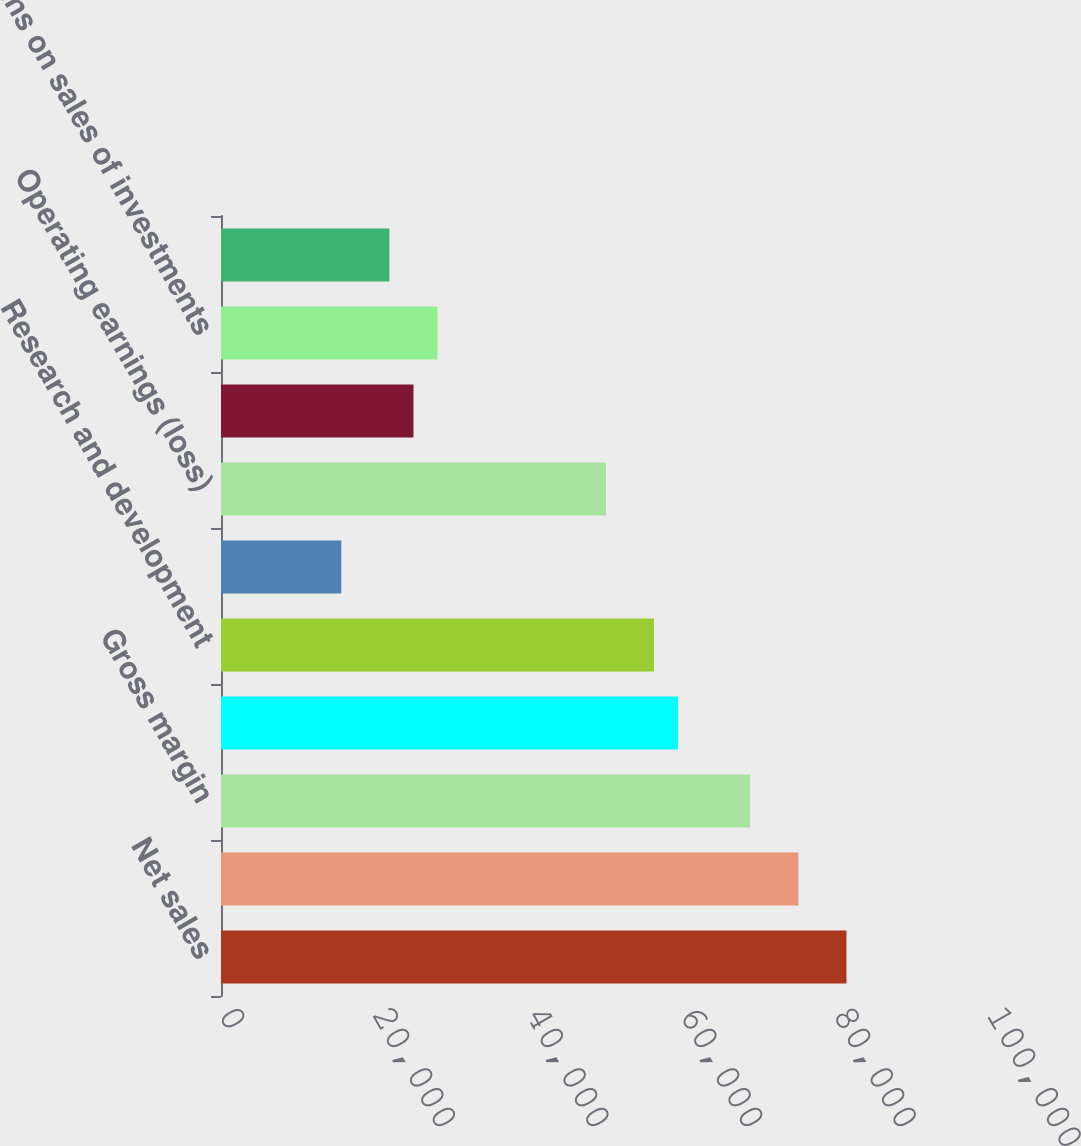Convert chart to OTSL. <chart><loc_0><loc_0><loc_500><loc_500><bar_chart><fcel>Net sales<fcel>Costs of sales<fcel>Gross margin<fcel>Selling general and<fcel>Research and development<fcel>Other charges (income)<fcel>Operating earnings (loss)<fcel>Interest income (expense) net<fcel>Gains on sales of investments<fcel>Other<nl><fcel>81439.4<fcel>75174.9<fcel>68910.3<fcel>59513.5<fcel>56381.2<fcel>15661.6<fcel>50116.6<fcel>25058.4<fcel>28190.7<fcel>21926.1<nl></chart> 